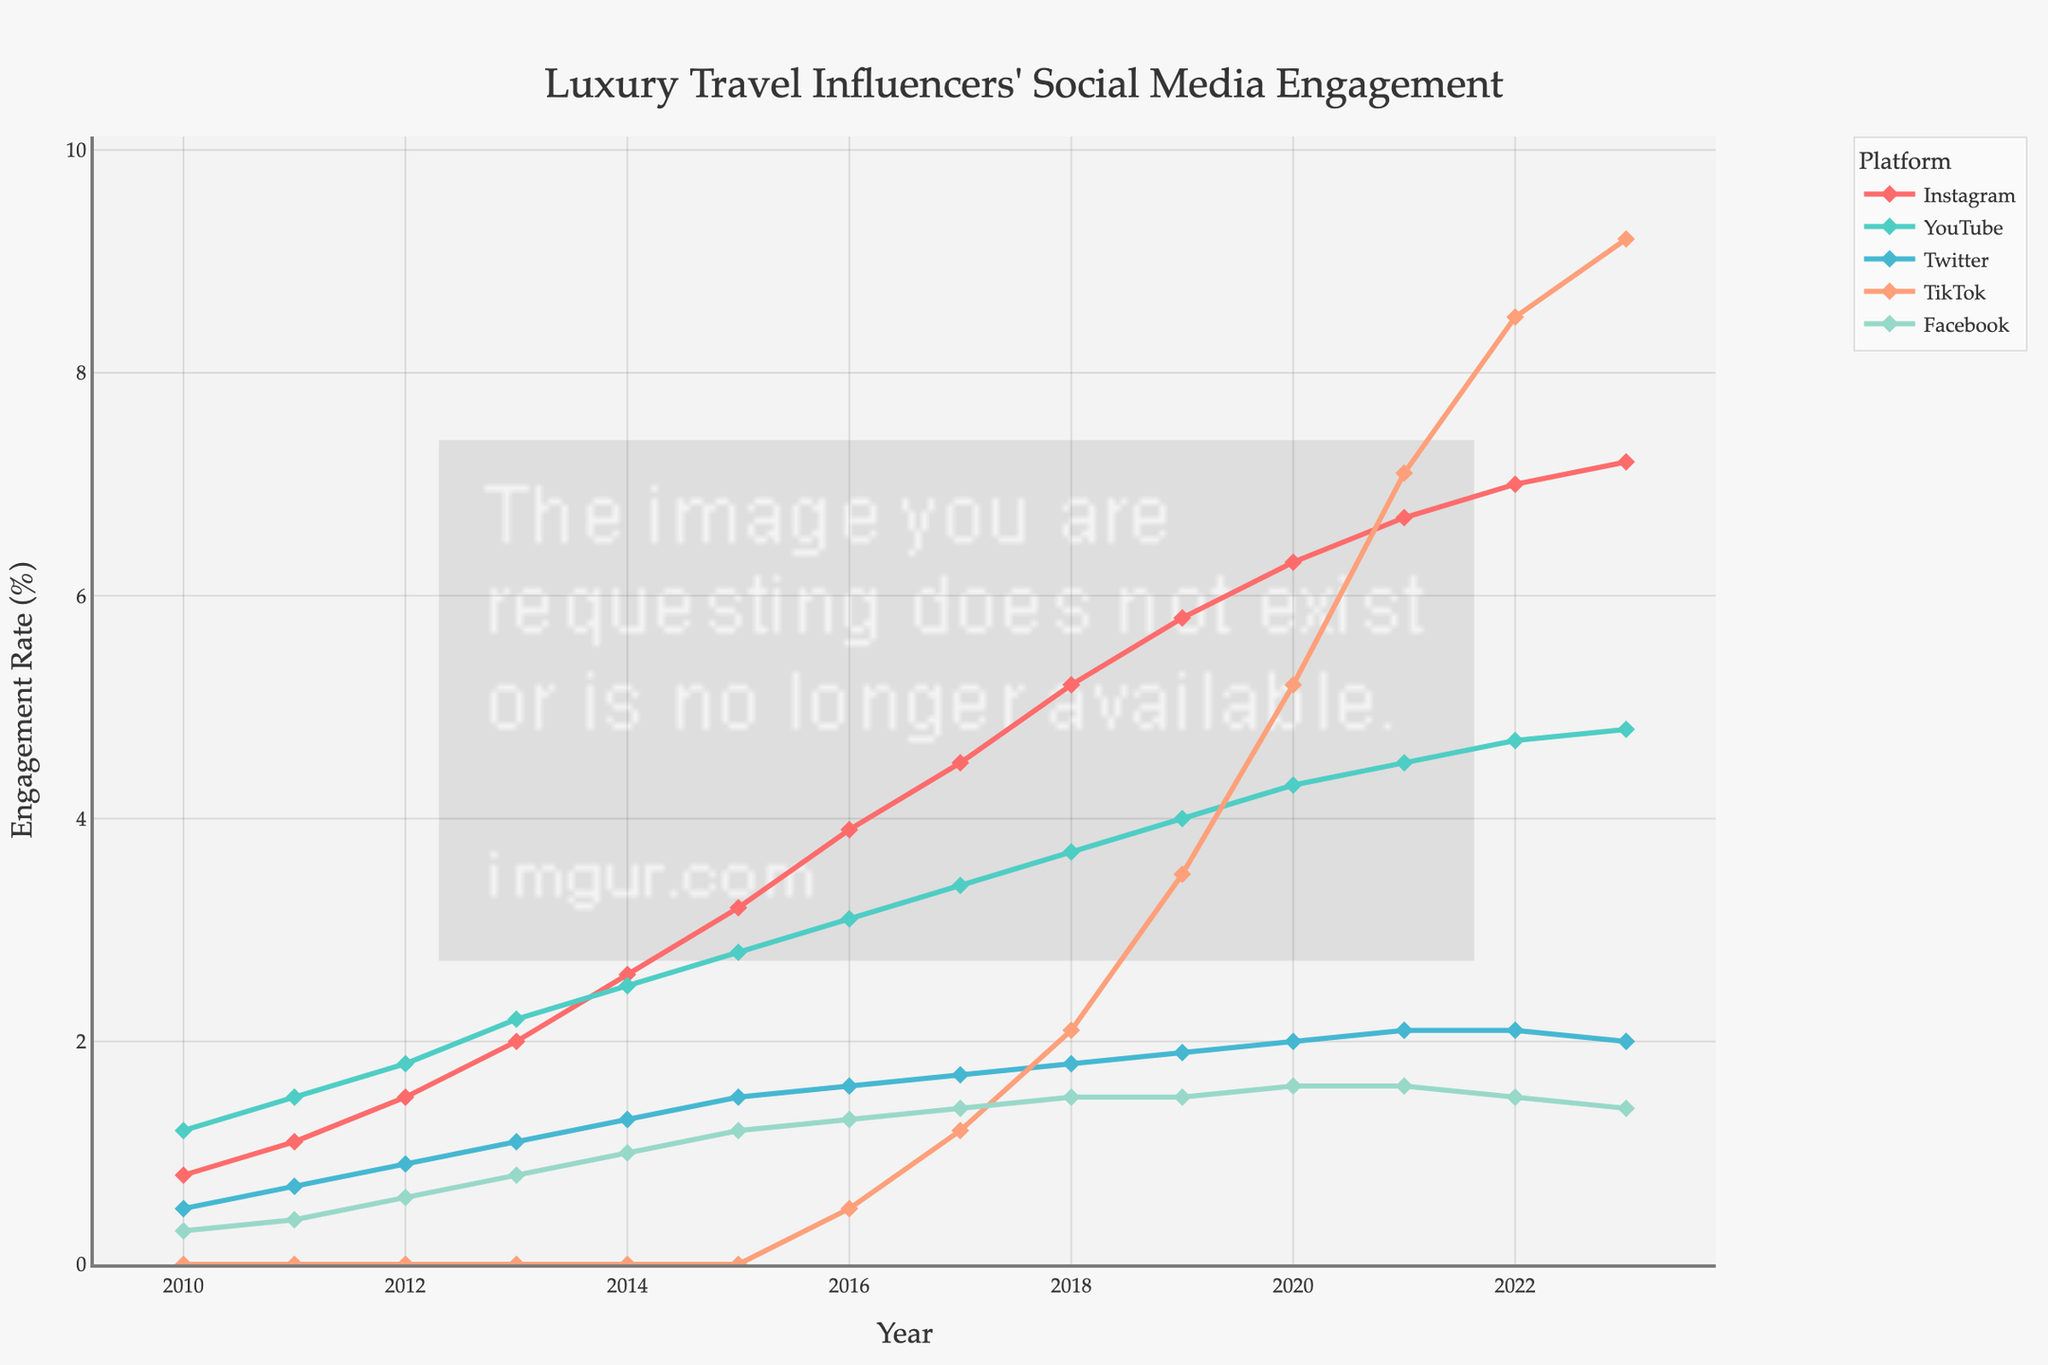Which platform had the highest engagement rate in 2023? To find the highest engagement rate for 2023, look at the y-values of all platforms for the year 2023 and identify the one that is highest. TikTok has the highest engagement rate in 2023 at 9.2%.
Answer: TikTok How did Instagram's engagement rate change from 2012 to 2014? Look at the y-values for Instagram in 2012 and 2014. Subtract the value from 2012 from the value in 2014: 2.6 - 1.5 = 1.1. Instagram’s engagement rate increased by 1.1% from 2012 to 2014.
Answer: Increased by 1.1% Which platform had a steady increase in engagement rate over the years? Examine the trend lines in the plot. A steady increase means the line should be consistently going up. Instagram shows a steady and consistent increase in engagement rate from 2010 to 2023.
Answer: Instagram In what year did TikTok surpass YouTube in engagement rate? Compare the y-values of TikTok and YouTube year by year to find when TikTok's value first becomes higher than YouTube's. TikTok surpasses YouTube in 2021.
Answer: 2021 What is the total engagement rate for all platforms in 2020? Sum the engagement rates for all platforms in 2020. Instagram (6.3) + YouTube (4.3) + Twitter (2.0) + TikTok (5.2) + Facebook (1.6) = 19.4. The total engagement rate for all platforms in 2020 is 19.4%.
Answer: 19.4% Which platform shows the biggest spike in engagement rate between consecutive years? Look for the largest difference between two consecutive points on any platform's line. TikTok shows the biggest spike between 2020 and 2021, where it jumps from 5.2% to 7.1%, an increase of 1.9%.
Answer: TikTok Is there any platform whose engagement rate decreased from 2022 to 2023? Compare the engagement rates for each platform in 2022 and 2023. Twitter's engagement rate decreased from 2.1% to 2.0%, and Facebook's rate decreased from 1.5% to 1.4%.
Answer: Twitter, Facebook 